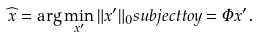<formula> <loc_0><loc_0><loc_500><loc_500>\widehat { x } = \arg \min _ { x ^ { \prime } } \| x ^ { \prime } \| _ { 0 } s u b j e c t t o y = \Phi x ^ { \prime } .</formula> 